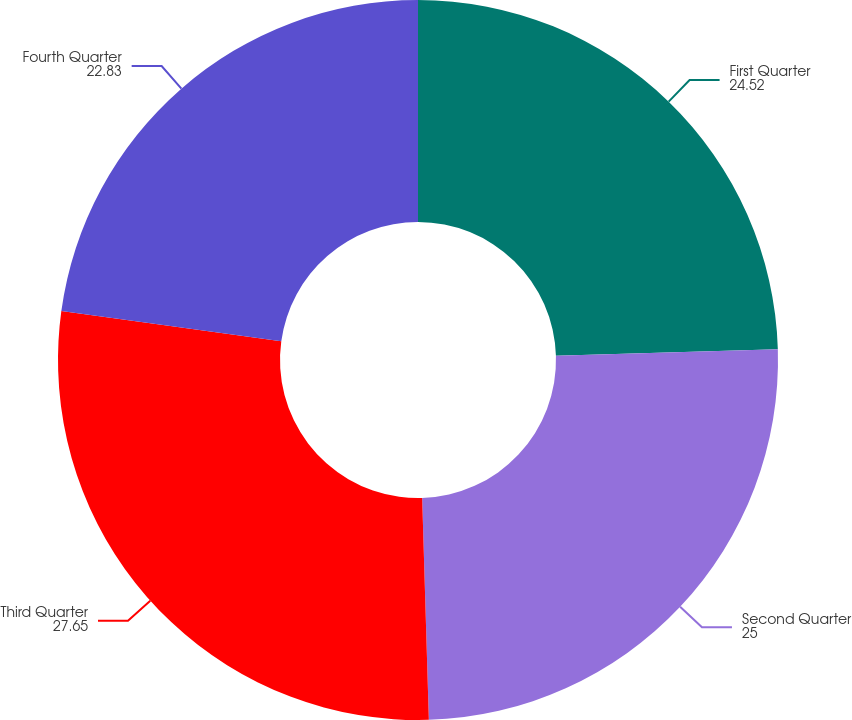Convert chart to OTSL. <chart><loc_0><loc_0><loc_500><loc_500><pie_chart><fcel>First Quarter<fcel>Second Quarter<fcel>Third Quarter<fcel>Fourth Quarter<nl><fcel>24.52%<fcel>25.0%<fcel>27.65%<fcel>22.83%<nl></chart> 